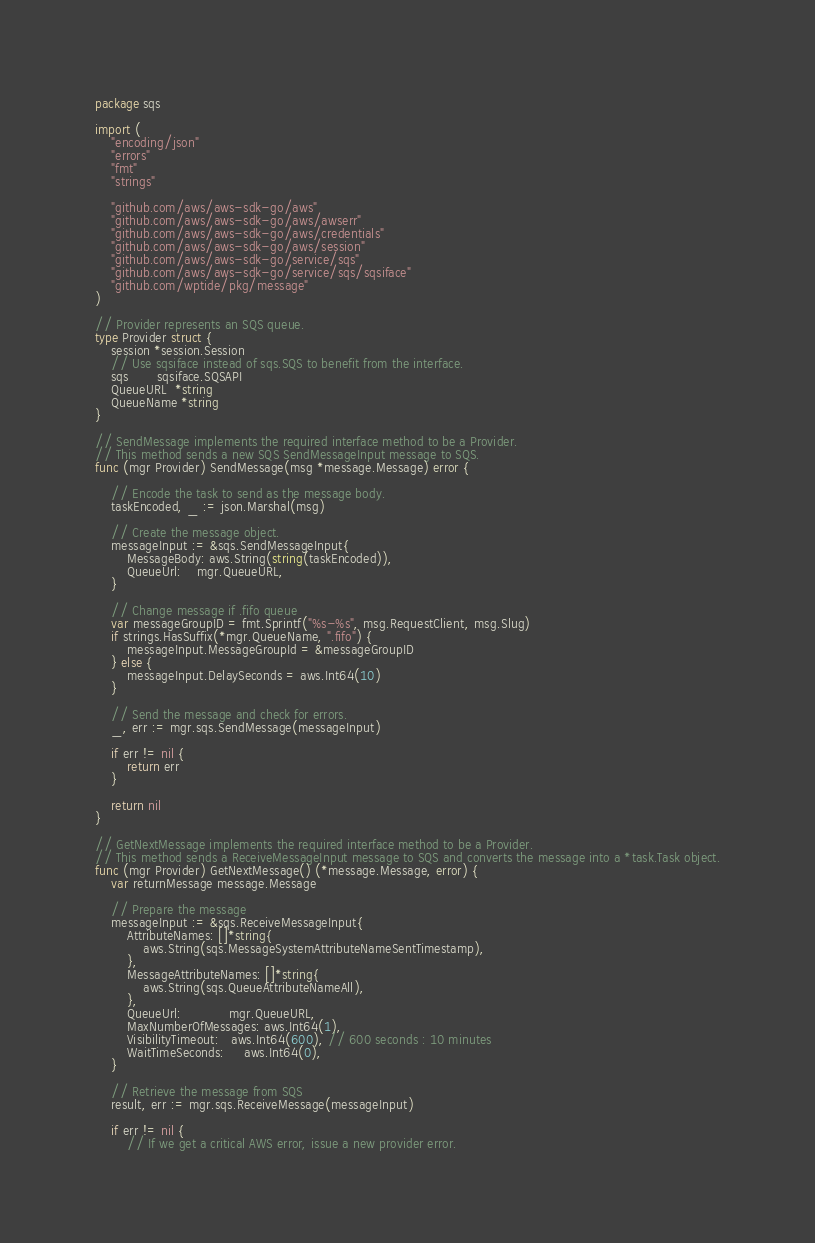Convert code to text. <code><loc_0><loc_0><loc_500><loc_500><_Go_>package sqs

import (
	"encoding/json"
	"errors"
	"fmt"
	"strings"

	"github.com/aws/aws-sdk-go/aws"
	"github.com/aws/aws-sdk-go/aws/awserr"
	"github.com/aws/aws-sdk-go/aws/credentials"
	"github.com/aws/aws-sdk-go/aws/session"
	"github.com/aws/aws-sdk-go/service/sqs"
	"github.com/aws/aws-sdk-go/service/sqs/sqsiface"
	"github.com/wptide/pkg/message"
)

// Provider represents an SQS queue.
type Provider struct {
	session *session.Session
	// Use sqsiface instead of sqs.SQS to benefit from the interface.
	sqs       sqsiface.SQSAPI
	QueueURL  *string
	QueueName *string
}

// SendMessage implements the required interface method to be a Provider.
// This method sends a new SQS SendMessageInput message to SQS.
func (mgr Provider) SendMessage(msg *message.Message) error {

	// Encode the task to send as the message body.
	taskEncoded, _ := json.Marshal(msg)

	// Create the message object.
	messageInput := &sqs.SendMessageInput{
		MessageBody: aws.String(string(taskEncoded)),
		QueueUrl:    mgr.QueueURL,
	}

	// Change message if .fifo queue
	var messageGroupID = fmt.Sprintf("%s-%s", msg.RequestClient, msg.Slug)
	if strings.HasSuffix(*mgr.QueueName, ".fifo") {
		messageInput.MessageGroupId = &messageGroupID
	} else {
		messageInput.DelaySeconds = aws.Int64(10)
	}

	// Send the message and check for errors.
	_, err := mgr.sqs.SendMessage(messageInput)

	if err != nil {
		return err
	}

	return nil
}

// GetNextMessage implements the required interface method to be a Provider.
// This method sends a ReceiveMessageInput message to SQS and converts the message into a *task.Task object.
func (mgr Provider) GetNextMessage() (*message.Message, error) {
	var returnMessage message.Message

	// Prepare the message
	messageInput := &sqs.ReceiveMessageInput{
		AttributeNames: []*string{
			aws.String(sqs.MessageSystemAttributeNameSentTimestamp),
		},
		MessageAttributeNames: []*string{
			aws.String(sqs.QueueAttributeNameAll),
		},
		QueueUrl:            mgr.QueueURL,
		MaxNumberOfMessages: aws.Int64(1),
		VisibilityTimeout:   aws.Int64(600), // 600 seconds : 10 minutes
		WaitTimeSeconds:     aws.Int64(0),
	}

	// Retrieve the message from SQS
	result, err := mgr.sqs.ReceiveMessage(messageInput)

	if err != nil {
		// If we get a critical AWS error, issue a new provider error.</code> 